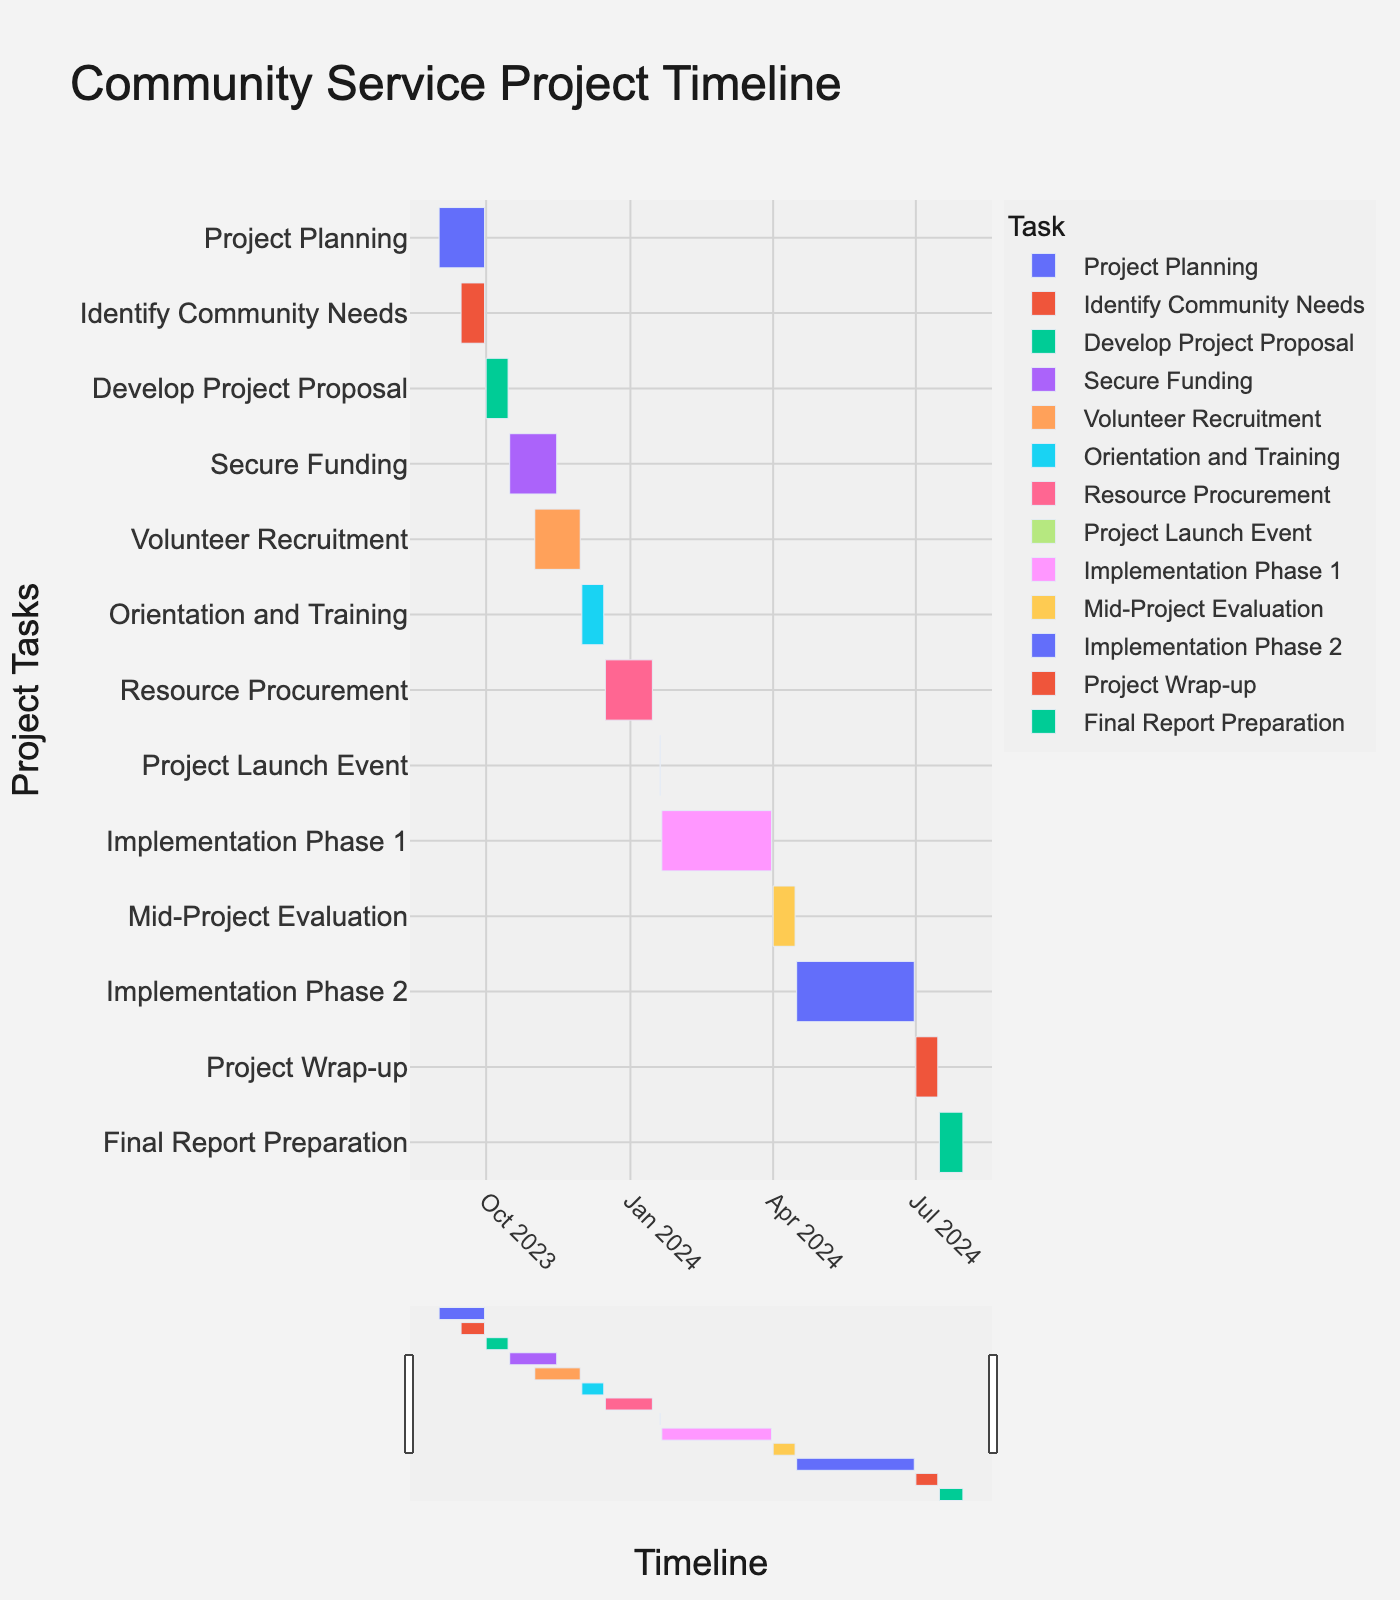How long is the Project Planning phase? Look at the start and end dates for "Project Planning." The start date is September 1, 2023 and the end date is September 30, 2023. Counting all the days from September 1 to September 30 gives 30 days.
Answer: 30 days When does the Volunteer Recruitment phase end? Find the "Volunteer Recruitment" task on the y-axis. The end date is November 30, 2023.
Answer: November 30, 2023 What tasks are planned for December 2023? Identify tasks that have start or end dates within December 2023. "Orientation and Training" from December 1 to December 15 and "Resource Procurement" starts on December 16.
Answer: Orientation and Training, Resource Procurement Which task starts immediately after the Project Planning phase? Check the end date of "Project Planning," which is September 30, 2023, and look for the task that starts immediately after. It is "Develop Project Proposal," which starts on October 1, 2023.
Answer: Develop Project Proposal How long is the gap between the end of Orientation and Training and the start of Resource Procurement? "Orientation and Training" ends on December 15, 2023, and "Resource Procurement" starts on December 16, 2023. The gap is from December 15 to December 16, which is 1 day.
Answer: 1 day Which task has the shortest duration? Compare the durations of all tasks by checking the start and end dates. The shortest duration is for "Project Launch Event," which is only one day on January 20, 2024.
Answer: Project Launch Event How many tasks are planned to be completed by the end of 2023? List all tasks that end on or before December 31, 2023: "Project Planning," "Identify Community Needs," "Develop Project Proposal," "Secure Funding," "Volunteer Recruitment," "Orientation and Training." There are six tasks.
Answer: 6 tasks What is the duration of the longest task in the implementation phase? Check the durations for "Implementation Phase 1" and "Implementation Phase 2." "Implementation Phase 1" is from January 21, 2024, to March 31, 2024 (70 days), and "Implementation Phase 2" is from April 16, 2024, to June 30, 2024 (76 days). "Implementation Phase 2" is longer.
Answer: 76 days What is the overlap period between "Identify Community Needs" and "Project Planning"? "Identify Community Needs" runs from September 15 to September 30, 2023, and "Project Planning" runs from September 1 to September 30, 2023. The overlap period is from September 15 to September 30, which is 15 days.
Answer: 15 days 